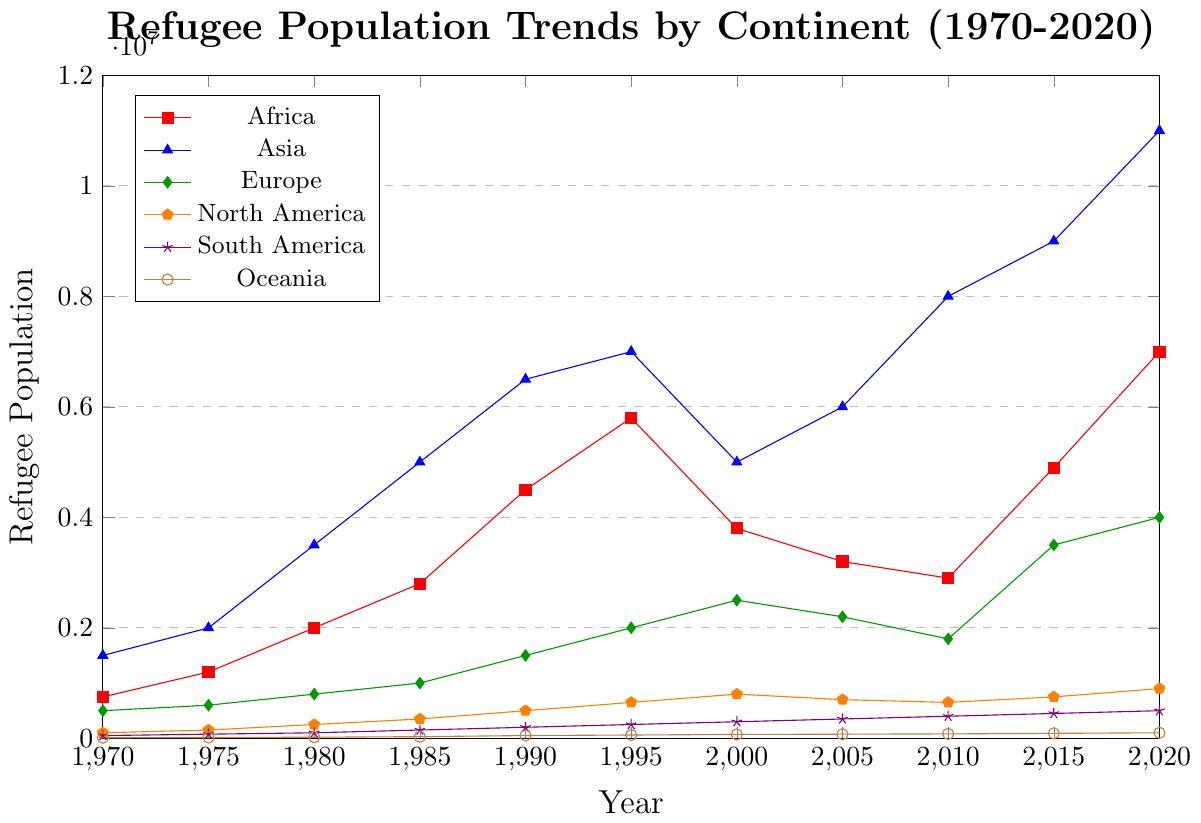What continent had the highest refugee population in 2020? Examine the lines on the graph; the line for Asia reaches the highest point in 2020, indicating that Asia had the highest refugee population.
Answer: Asia Which continent's refugee population saw the largest increase from 1970 to 2020? To determine the continent with the largest increase, subtract the refugee population of 1970 from the population of 2020 for each continent. Asia's increase is 11,000,000 - 1,500,000 = 9,500,000, which is the largest among all continents.
Answer: Asia What is the difference between the refugee populations of Europe and North America in 2020? Subtract the refugee population of North America in 2020 from that of Europe. Europe had 4,000,000 and North America had 900,000. The difference is 4,000,000 - 900,000 = 3,100,000.
Answer: 3,100,000 Compare the refugee population trends of Africa and South America between 1970 and 1995. Which continent had a more stable trend? Examine the lines for Africa and South America between 1970 and 1995. Africa shows a sharp increase from 750,000 to 5,800,000, while South America shows a more gradual increase from 50,000 to 250,000. Therefore, South America had a more stable trend.
Answer: South America What is the total number of refugees in Oceania across all years? Sum the refugee populations of Oceania for all years: 10,000 + 15,000 + 20,000 + 30,000 + 50,000 + 60,000 + 70,000 + 75,000 + 80,000 + 90,000 + 100,000. The total is 600,000.
Answer: 600,000 Between which two consecutive years did Asia see the greatest increase in refugee population? Find the differences between consecutive years for Asia's refugee population and identify the greatest increase: 
1975-1970: 500,000 
1980-1975: 1,500,000 
1985-1980: 1,500,000 
1990-1985: 1,500,000 
1995-1990: 500,000 
2000-1995: -2,000,000  
2005-2000: 1,000,000 
2010-2005: 2,000,000 
2015-2010: 1,000,000 
2020-2015: 2,000,000.
The greatest increase is 2,000,000 between 2005-2010 and 2015-2020.
Answer: 2005-2010 and 2015-2020 Was there any year when Africa's refugee population decreased compared to the previous year? If so, which year? Analyze the trend line for Africa. The refugee population decreases from 1995 (5,800,000) to 2000 (3,800,000).
Answer: 2000 Which continent had the lowest refugee population in 1970, and what was the population? By examining the initial year (1970) data points, Oceania had the lowest refugee population of 10,000.
Answer: Oceania, 10,000 What is the average refugee population in Asia over the last 50 years? Sum the refugee populations of Asia for all years and divide by the number of years (11): 
(1,500,000 + 2,000,000 + 3,500,000 + 5,000,000 + 6,500,000 + 7,000,000 + 5,000,000 + 6,000,000 + 8,000,000 + 9,000,000 + 11,000,000) = 64,500,000. 
64,500,000/11 ≈ 5,863,636.
Answer: 5,863,636 